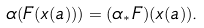Convert formula to latex. <formula><loc_0><loc_0><loc_500><loc_500>\alpha ( F ( x ( a ) ) ) = ( \alpha _ { * } F ) ( x ( a ) ) .</formula> 